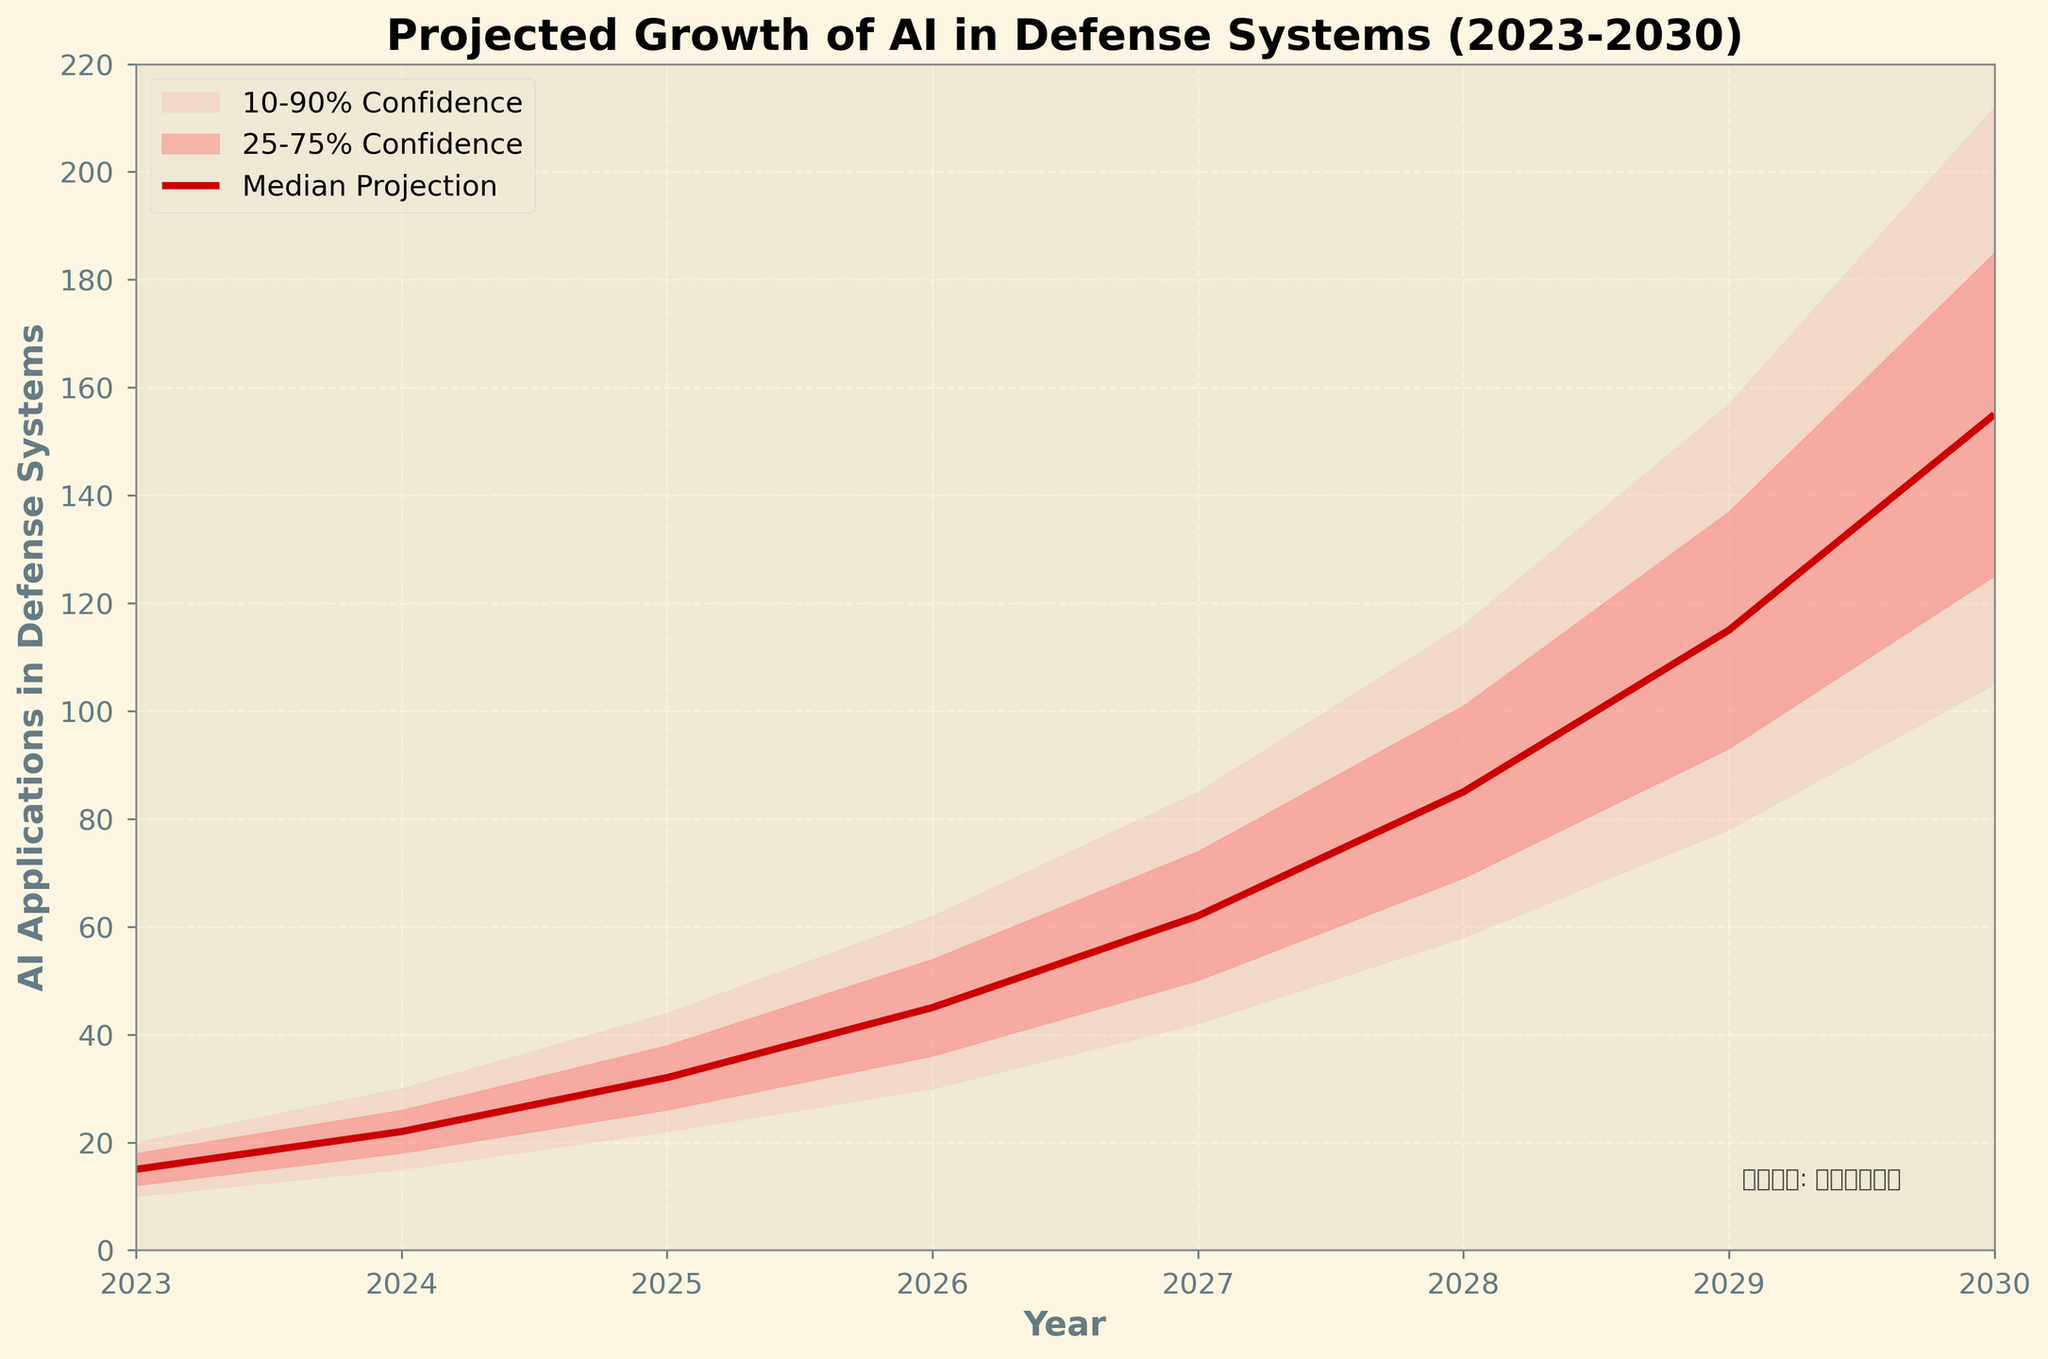What is the title of the figure? The title is usually placed at the top of the figure and describes the main topic of the visualization. In this case, the title is prominently displayed as "Projected Growth of AI in Defense Systems (2023-2030)."
Answer: Projected Growth of AI in Defense Systems (2023-2030) How is the median projection trend represented in the chart? The median projection trend is usually represented by a line on a fan chart. Here, a bold red line (color not specified in coding terms) is used to indicate the median projection over the years 2023 to 2030.
Answer: A bold red line What do the shaded areas in the chart represent? In a fan chart, shaded areas indicate confidence intervals. The lighter shaded area represents the 10-90% confidence interval, while the darker shaded area represents the 25-75% confidence interval. These areas describe the range within which the projections are expected to fall.
Answer: Confidence intervals (10-90% and 25-75%) What is the projected median value of AI applications in defense systems for the year 2027? The median projection for any given year is represented by the value of the bold red line at that year. For 2027, it corresponds to 62.
Answer: 62 Which year shows the largest projected growth in the median value of AI applications in defense systems? To determine the year with the largest growth, we need to calculate the year-on-year differences in the median values. The largest difference is between 2029 and 2030, which is calculated as 155 - 115 = 40.
Answer: 2029 to 2030 By how much does the upper 90% confidence interval increase from 2025 to 2028? The upper 90% confidence interval values need to be subtracted for 2028 (116) and 2025 (44). The increase is 116 - 44 = 72.
Answer: 72 What is the trend in the lower 10% confidence interval over the forecast period? By looking at the lower boundary of the shaded area, we can observe that the lower 10% confidence interval steadily increases from 10 in 2023 to 105 in 2030.
Answer: Increasing Compare the 25th and 75th percentiles of AI applications in defense for the year 2026. Which percentile shows a higher value and by how much? The 75th percentile (upper bound of the darker shaded area) for 2026 is 54, and the 25th percentile (lower bound of the darker shaded area) is 36. The difference is 54 - 36 = 18, showing that the 75th percentile is higher by this amount.
Answer: 75th percentile by 18 How does the grid affect the readability of the chart? A grid with dashed lines is used to enhance readability by helping the viewer align data points with the axes more easily. This makes it simpler to compare values and observe trends.
Answer: Enhances readability What additional information is provided at the bottom of the chart? There is a text note at the bottom right corner of the chart stating "数据来源: 国防分析报告," which translates to "Source: Defense Analysis Report." This indicates the origin of the data used in the chart.
Answer: Source: Defense Analysis Report 